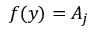<formula> <loc_0><loc_0><loc_500><loc_500>f ( y ) = A _ { j }</formula> 